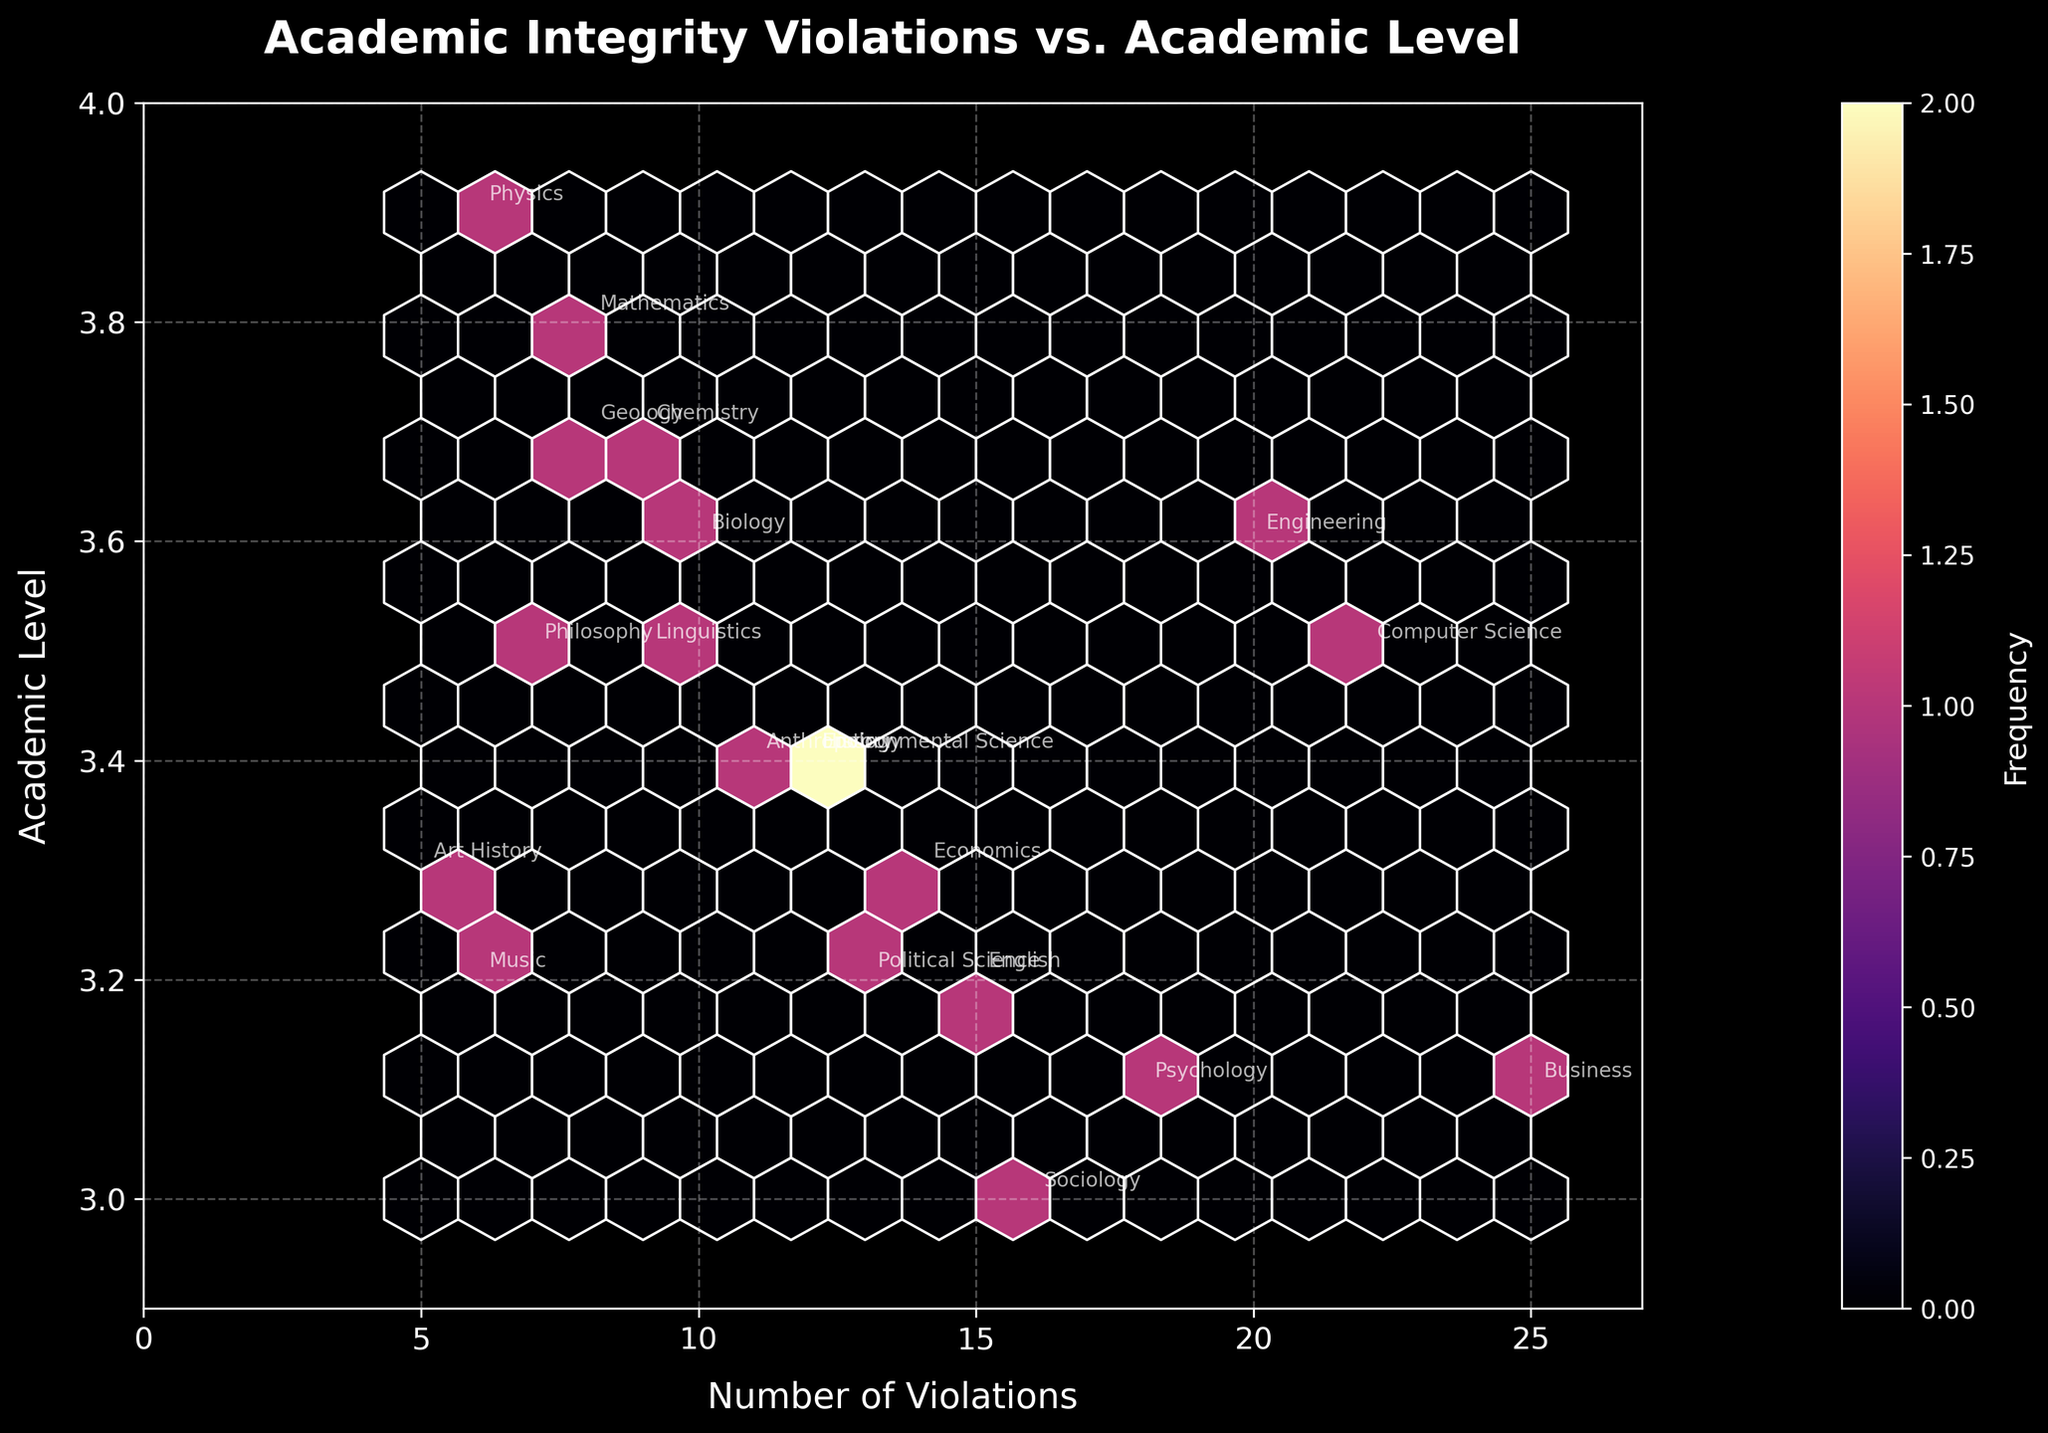What's the title of the figure? The title is located at the top-center of the figure and is displayed prominently in bold.
Answer: Academic Integrity Violations vs. Academic Level How many axis labels are there in the plot? The plot has an x-axis and a y-axis, each with one label describing the variable it represents.
Answer: 2 Which department has the highest number of violations? By looking at the hexbins and annotations, the department with the highest number of violations is evident. Specifically, "Business" is annotated with 25 violations.
Answer: Business What is the range of the x-axis? The x-axis represents the number of violations. The range can be determined by observing the minimum and maximum values marked on the axis.
Answer: 0 to 27 Which department has the lowest academic level? The y-axis represents the academic level. By identifying the annotation with the lowest y-coordinate, "Sociology" appears at the lowest level of 3.0.
Answer: Sociology What departments have violations greater than 20? We need to locate all departments that fall to the right of the x=20 mark on the x-axis. "Computer Science" and "Business" meet this criterion with violations of 22 and 25, respectively.
Answer: Computer Science, Business Between which academic levels does the majority of the data fall? We estimate the density of data points by assessing the hexbins and examine the clustering of y-values. The majority appear to be between the academic levels of 3.0 and 3.6.
Answer: 3.0 and 3.6 How would you describe the Hexbin plot color distribution? The Hexbin plot color ranges from dark to light, where lighter colors indicate higher frequency.
Answer: Dark to light; lighter colors indicate higher frequency Which department, annotated at an academic level of 3.3, has approximately 14 violations? By locating the y-coordinate of 3.3 and then finding the corresponding department near the 14 violations mark, "Economics" fits this description.
Answer: Economics Which departments fall within the academic level range of 3.5 to 3.7? Reviewing departments annotated between these y-values can identify "Philosophy," "Biology," "Chemistry," and "Geology."
Answer: Philosophy, Biology, Chemistry, Geology 